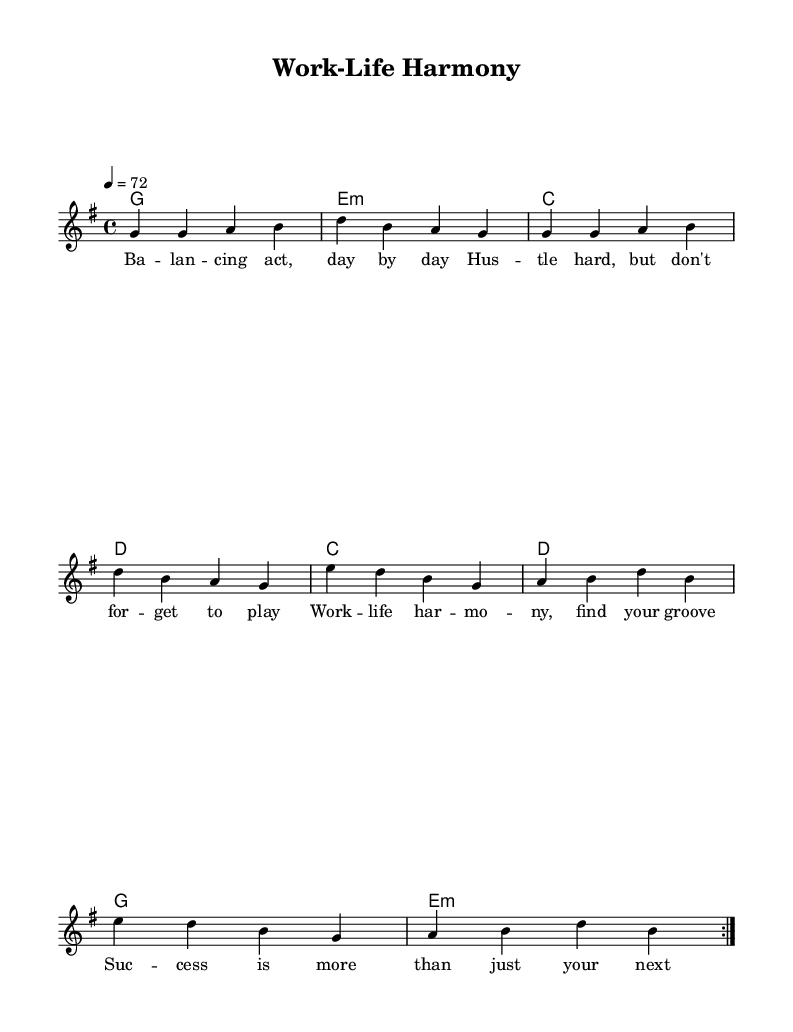What is the key signature of this music? The key signature is G major, which has one sharp (F#). The key is indicated at the beginning of the staff with the sharp sign.
Answer: G major What is the time signature of this piece? The time signature is 4/4, shown at the beginning of the score. This means there are four beats in each measure.
Answer: 4/4 What is the tempo marking for this tune? The tempo marking indicates a speed of 72 beats per minute, shown with "4 = 72". This signifies the metronome setting for this piece.
Answer: 72 How many times is the melody repeated? The melody is repeated twice, as indicated by the "repeat volta 2" instruction in the score, which specifies that the section should be played two times.
Answer: 2 What does the first line of lyrics emphasize? The first line of lyrics, "Balancing act, day by day", emphasizes the theme of daily life management between work and personal time. It highlights the struggle young professionals face.
Answer: Balancing act What is the overall theme conveyed in the lyrics? The lyrics explore the concept of work-life harmony, suggesting that success is not just about professional achievements but also about enjoying life. This is derived from phrases like "work-life harmony" and "success is more than just your next move".
Answer: Work-life harmony What does the repeated chord G represent in this song? The repeated chord G can suggest a relaxed and uplifting vibe typical in reggae music, reinforcing a sense of stability and positivity in the pursuit of work-life balance. It establishes the key foundation for the laid-back feel of this genre.
Answer: Stability 